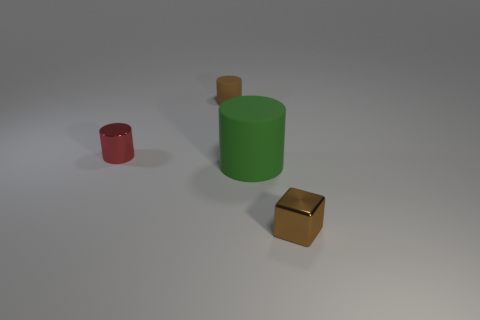Add 2 small red metallic objects. How many objects exist? 6 Subtract all blocks. How many objects are left? 3 Subtract 0 cyan cylinders. How many objects are left? 4 Subtract all tiny cyan matte cylinders. Subtract all metallic things. How many objects are left? 2 Add 2 brown rubber objects. How many brown rubber objects are left? 3 Add 2 tiny metallic cubes. How many tiny metallic cubes exist? 3 